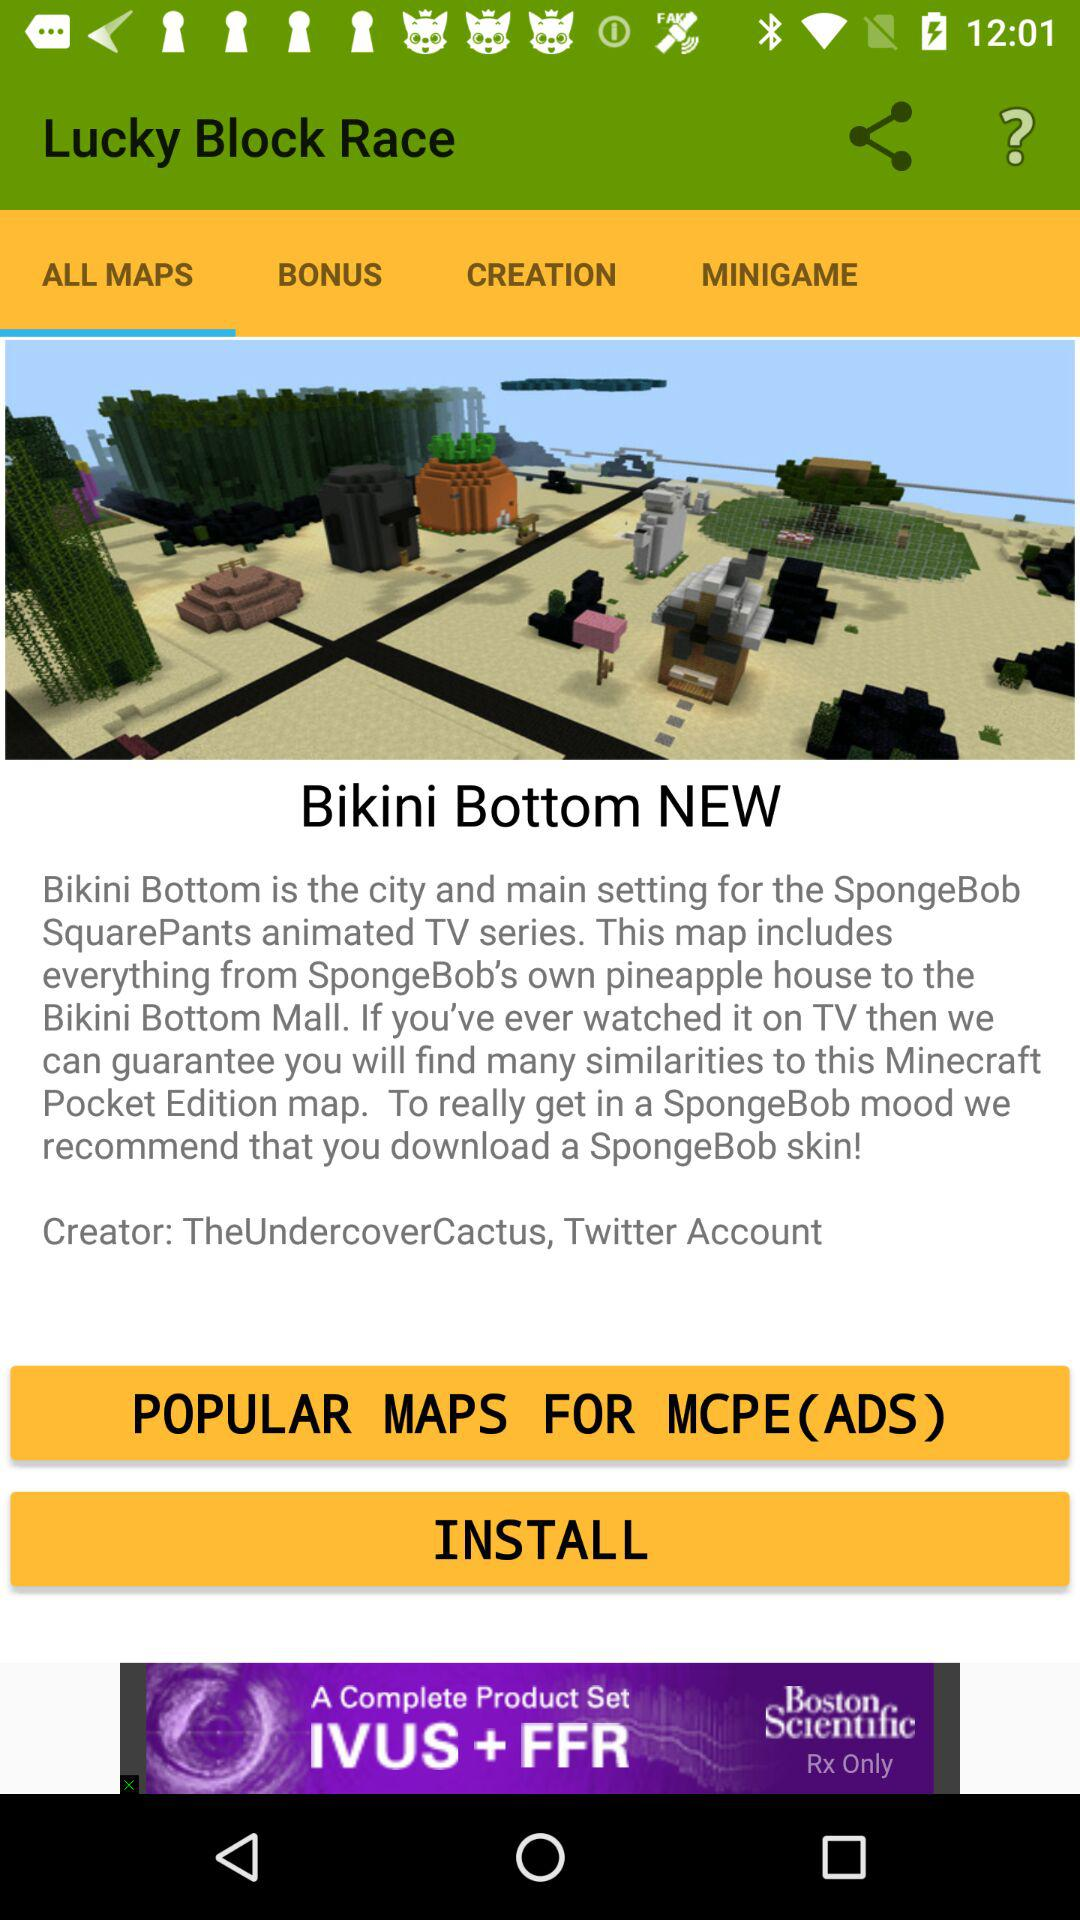What is the name of the animated TV series? The name of the animated TV series is "SpongeBob SquarePants". 